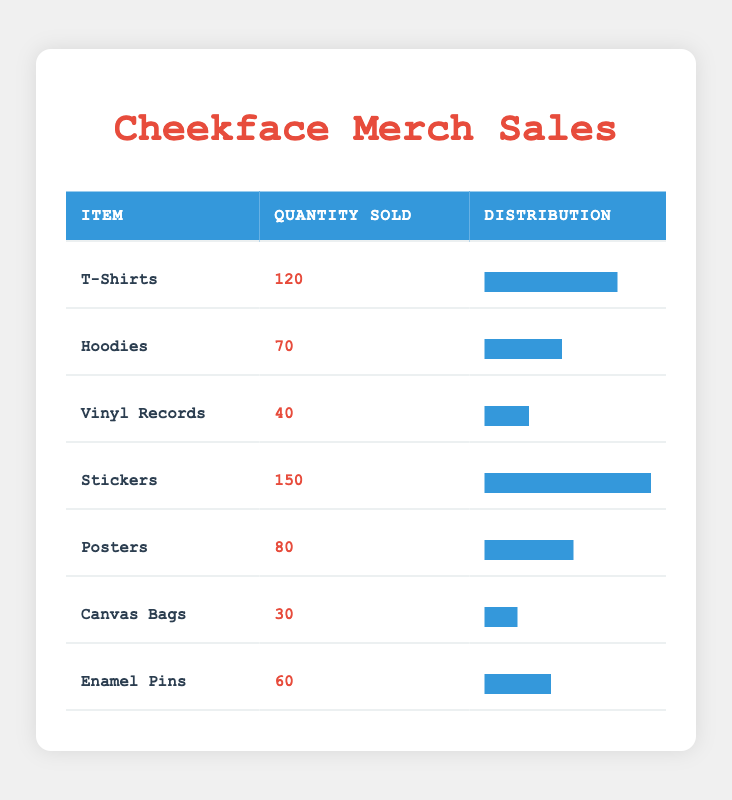What item sold the most at the concerts? Looking at the 'Quantity Sold' column, 'Stickers' have the highest quantity sold at 150.
Answer: Stickers How many T-Shirts were sold at the concerts? The table clearly shows that the quantity sold for T-Shirts is 120.
Answer: 120 What is the total quantity of all merchandise sold? To find the total quantity, add all the quantities: 120 + 70 + 40 + 150 + 80 + 30 + 60 = 550.
Answer: 550 Did more Hoodies or Enamel Pins sell at the concerts? Hoodies sold 70 while Enamel Pins sold 60. Since 70 is greater than 60, more Hoodies were sold.
Answer: Yes, more Hoodies sold What is the average quantity sold of all the merchandise items? The average can be calculated by summing the quantities (550) and dividing by the number of items (7): 550 / 7 ≈ 78.57.
Answer: Approximately 78.57 Which merchandise has the lowest sales, and what was the quantity sold? The 'Canvas Bags' row displays the lowest quantity sold, which is 30.
Answer: Canvas Bags, 30 If the quantity of Vinyl Records sold increased by 10, what would be the new total quantity sold? First, increase the current Vinyl Records quantity sold (40) by 10 to get 50. Then, calculate the new total: 550 - 40 + 50 = 560.
Answer: 560 